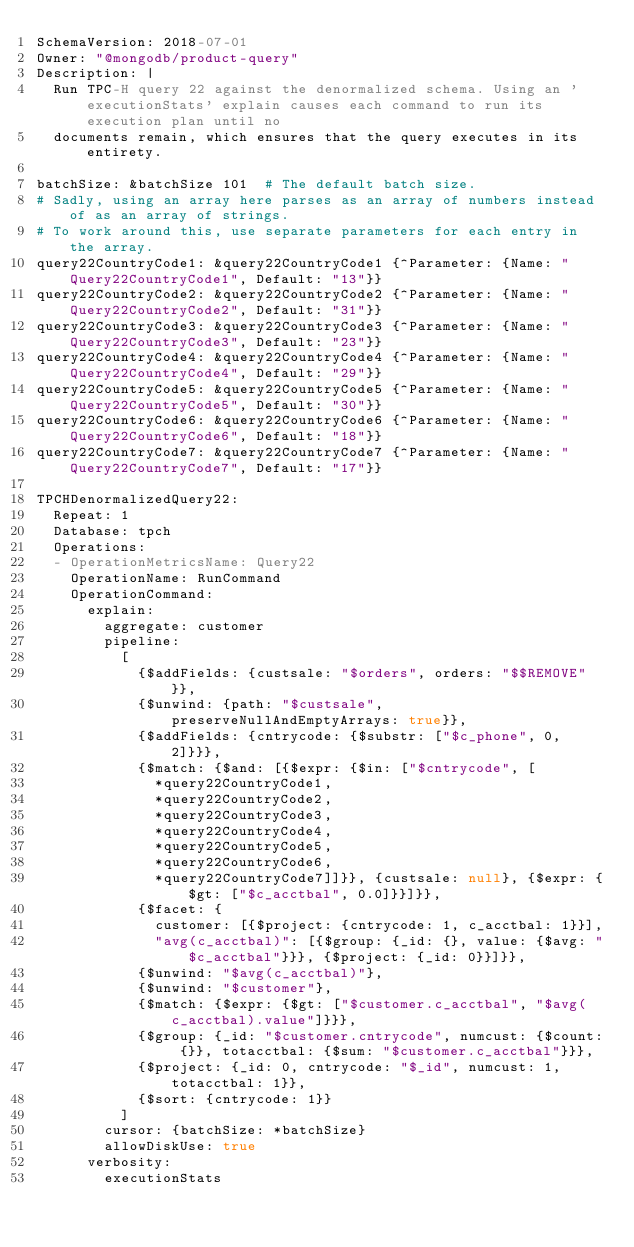<code> <loc_0><loc_0><loc_500><loc_500><_YAML_>SchemaVersion: 2018-07-01
Owner: "@mongodb/product-query"
Description: |
  Run TPC-H query 22 against the denormalized schema. Using an 'executionStats' explain causes each command to run its execution plan until no
  documents remain, which ensures that the query executes in its entirety.

batchSize: &batchSize 101  # The default batch size.
# Sadly, using an array here parses as an array of numbers instead of as an array of strings.
# To work around this, use separate parameters for each entry in the array.
query22CountryCode1: &query22CountryCode1 {^Parameter: {Name: "Query22CountryCode1", Default: "13"}}
query22CountryCode2: &query22CountryCode2 {^Parameter: {Name: "Query22CountryCode2", Default: "31"}}
query22CountryCode3: &query22CountryCode3 {^Parameter: {Name: "Query22CountryCode3", Default: "23"}}
query22CountryCode4: &query22CountryCode4 {^Parameter: {Name: "Query22CountryCode4", Default: "29"}}
query22CountryCode5: &query22CountryCode5 {^Parameter: {Name: "Query22CountryCode5", Default: "30"}}
query22CountryCode6: &query22CountryCode6 {^Parameter: {Name: "Query22CountryCode6", Default: "18"}}
query22CountryCode7: &query22CountryCode7 {^Parameter: {Name: "Query22CountryCode7", Default: "17"}}

TPCHDenormalizedQuery22:
  Repeat: 1
  Database: tpch
  Operations:
  - OperationMetricsName: Query22
    OperationName: RunCommand
    OperationCommand:
      explain:
        aggregate: customer
        pipeline:
          [
            {$addFields: {custsale: "$orders", orders: "$$REMOVE"}},
            {$unwind: {path: "$custsale", preserveNullAndEmptyArrays: true}},
            {$addFields: {cntrycode: {$substr: ["$c_phone", 0, 2]}}},
            {$match: {$and: [{$expr: {$in: ["$cntrycode", [
              *query22CountryCode1,
              *query22CountryCode2,
              *query22CountryCode3,
              *query22CountryCode4,
              *query22CountryCode5,
              *query22CountryCode6,
              *query22CountryCode7]]}}, {custsale: null}, {$expr: {$gt: ["$c_acctbal", 0.0]}}]}},
            {$facet: {
              customer: [{$project: {cntrycode: 1, c_acctbal: 1}}],
              "avg(c_acctbal)": [{$group: {_id: {}, value: {$avg: "$c_acctbal"}}}, {$project: {_id: 0}}]}},
            {$unwind: "$avg(c_acctbal)"},
            {$unwind: "$customer"},
            {$match: {$expr: {$gt: ["$customer.c_acctbal", "$avg(c_acctbal).value"]}}},
            {$group: {_id: "$customer.cntrycode", numcust: {$count: {}}, totacctbal: {$sum: "$customer.c_acctbal"}}},
            {$project: {_id: 0, cntrycode: "$_id", numcust: 1, totacctbal: 1}},
            {$sort: {cntrycode: 1}}
          ]
        cursor: {batchSize: *batchSize}
        allowDiskUse: true
      verbosity:
        executionStats
</code> 